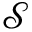Convert formula to latex. <formula><loc_0><loc_0><loc_500><loc_500>\mathcal { S }</formula> 